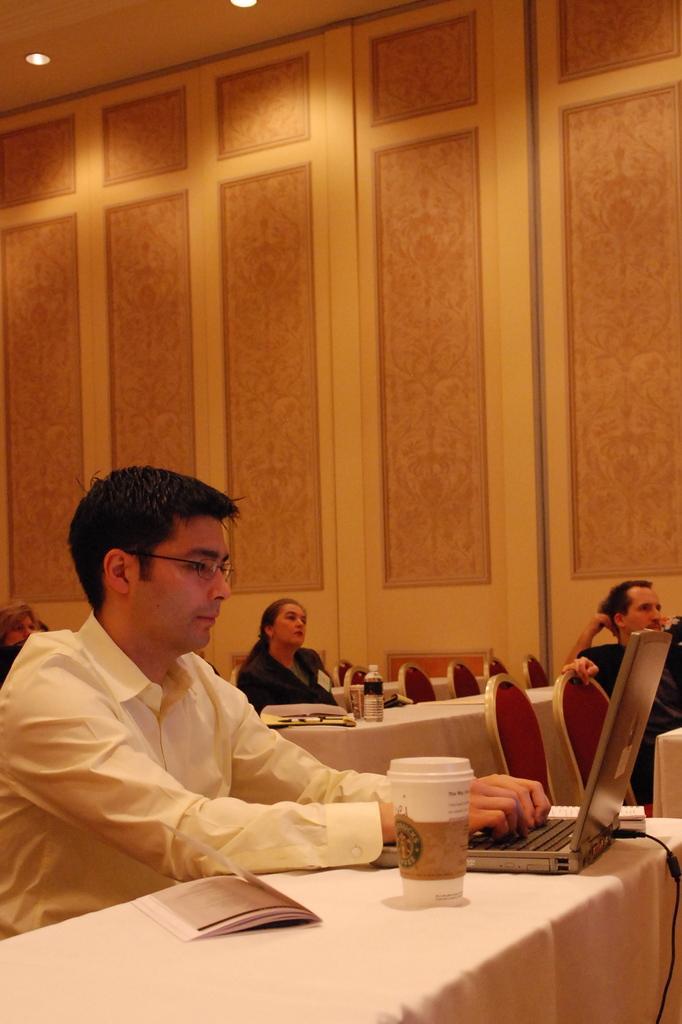Describe this image in one or two sentences. In this picture we can see persons sitting on chairs,here we can see tables,laptop,bottle and in the background we can see a wall. 